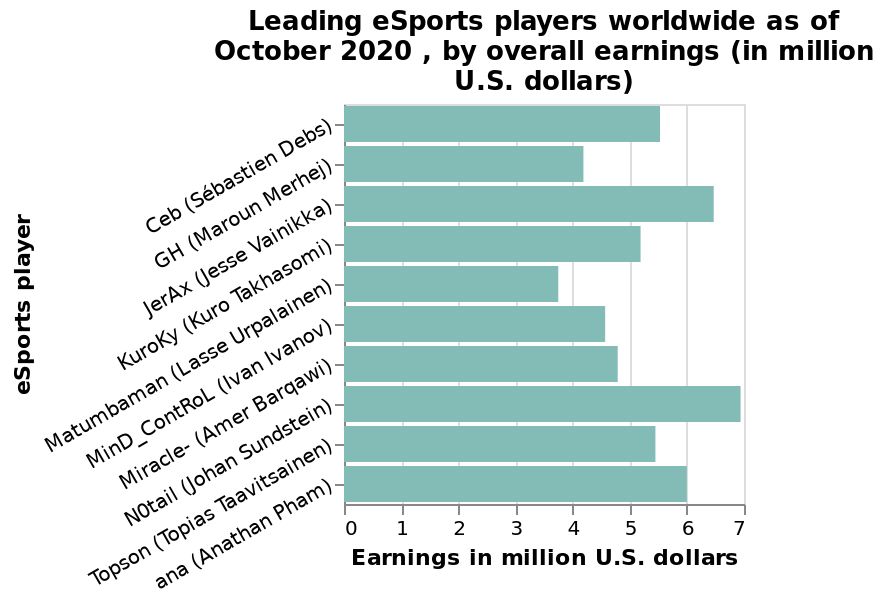<image>
Who has the highest gross earnings among the represented players? N0tail has the highest gross earnings among the represented players. What is the range of the x-axis? The range of the x-axis is from 0 to 7 million U.S. dollars. Who is the last player on the bar plot?  The last player on the bar plot is ana (Anathan Pham). What does the x-axis represent?  The x-axis represents earnings in million U.S. dollars. Offer a thorough analysis of the image. N0tail has the largest gross earnings of all represented, with Matumbaman having the least. Who is the first player on the bar plot?  The first player on the bar plot is Ceb (Sébastien Debs). 